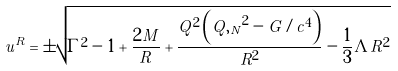<formula> <loc_0><loc_0><loc_500><loc_500>u ^ { R } = \pm \sqrt { \Gamma ^ { 2 } - 1 + \frac { 2 M } R + \frac { Q ^ { 2 } \left ( { Q , _ { N } } ^ { 2 } - G / c ^ { 4 } \right ) } { R ^ { 2 } } - \frac { 1 } { 3 } \Lambda R ^ { 2 } }</formula> 